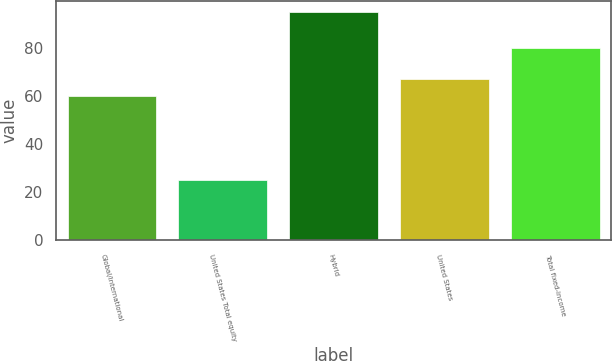<chart> <loc_0><loc_0><loc_500><loc_500><bar_chart><fcel>Global/international<fcel>United States Total equity<fcel>Hybrid<fcel>United States<fcel>Total fixed-income<nl><fcel>60<fcel>25<fcel>95<fcel>67<fcel>80<nl></chart> 